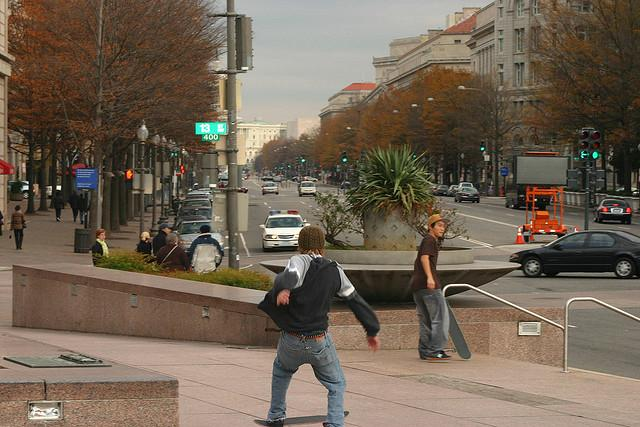Why plants are planted on roadside? Please explain your reasoning. wind breaks. The plants are use to stop the wind. 